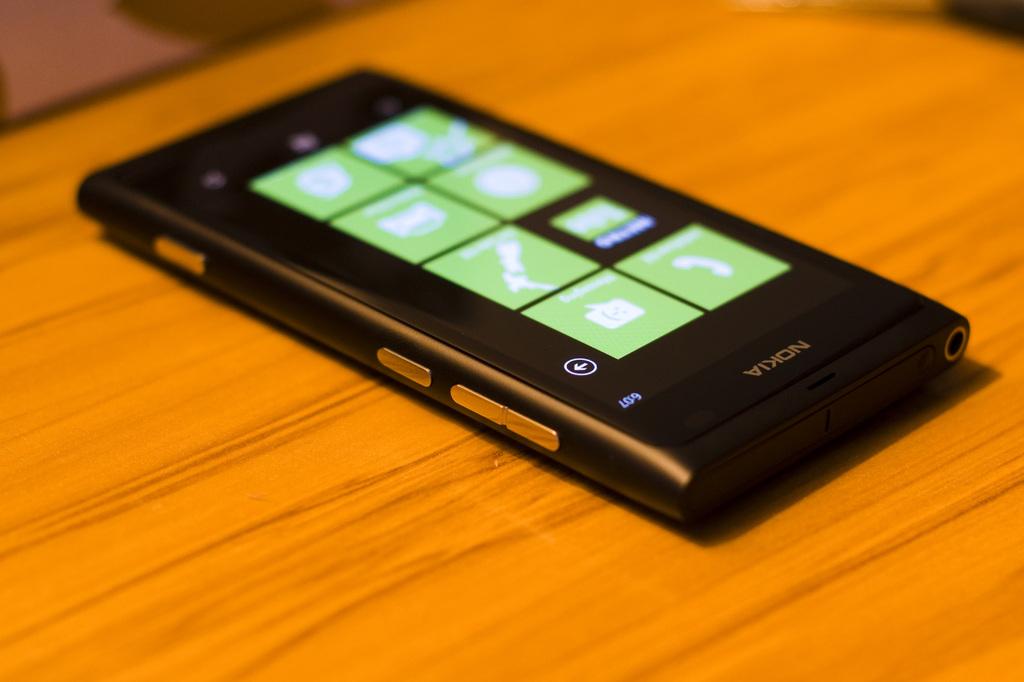What is the brand of this phone?
Your response must be concise. Nokia. What time does the phone say?
Offer a very short reply. 6:07. 